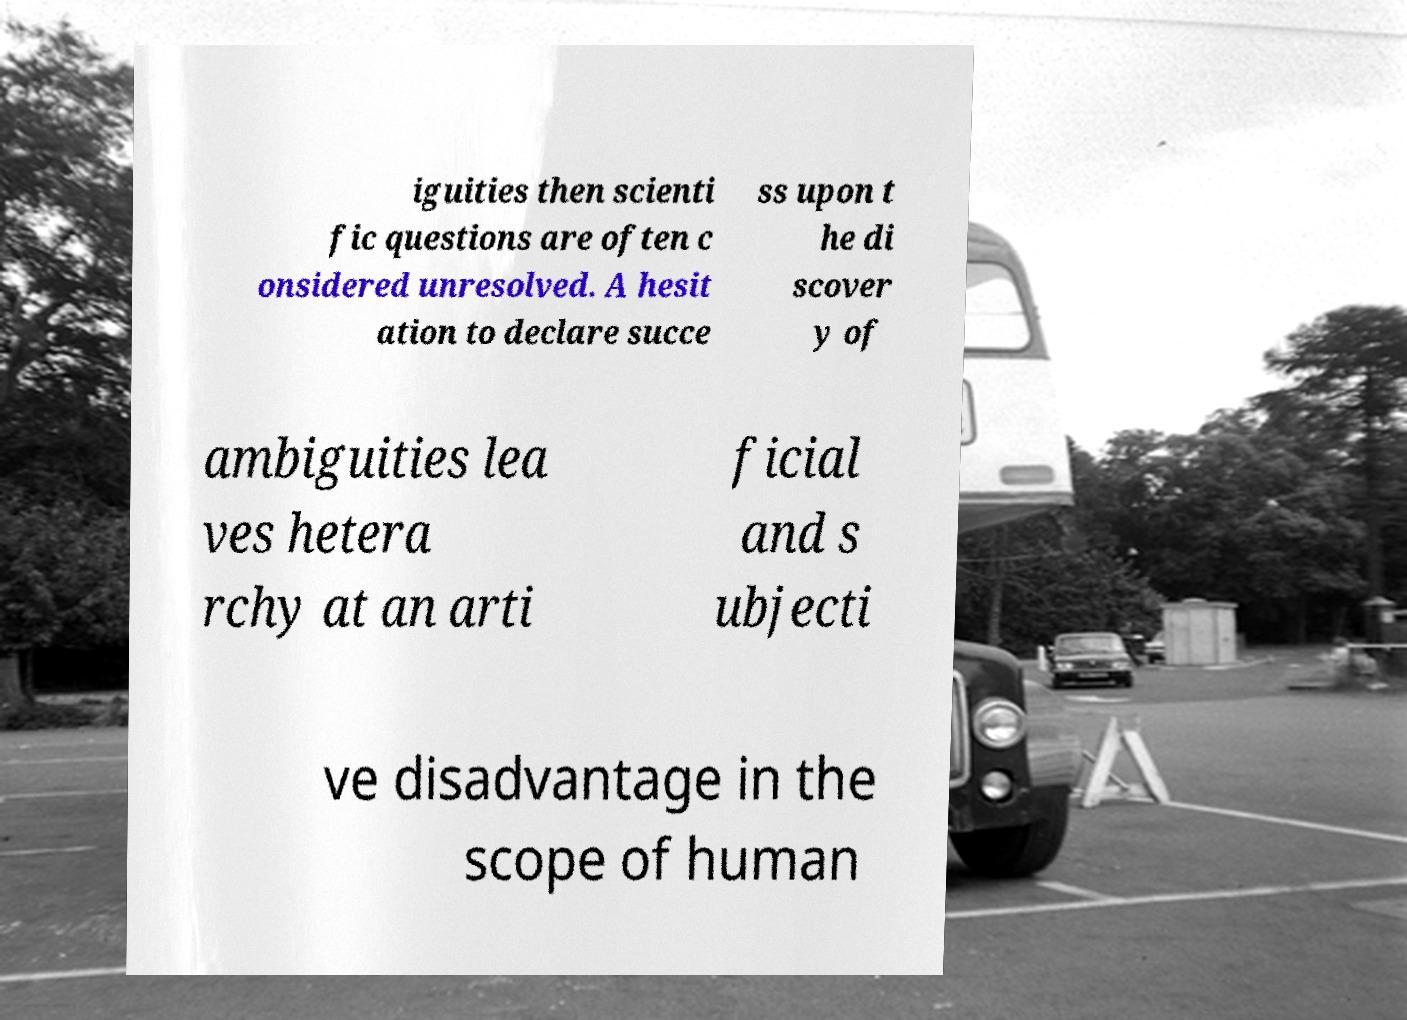For documentation purposes, I need the text within this image transcribed. Could you provide that? iguities then scienti fic questions are often c onsidered unresolved. A hesit ation to declare succe ss upon t he di scover y of ambiguities lea ves hetera rchy at an arti ficial and s ubjecti ve disadvantage in the scope of human 